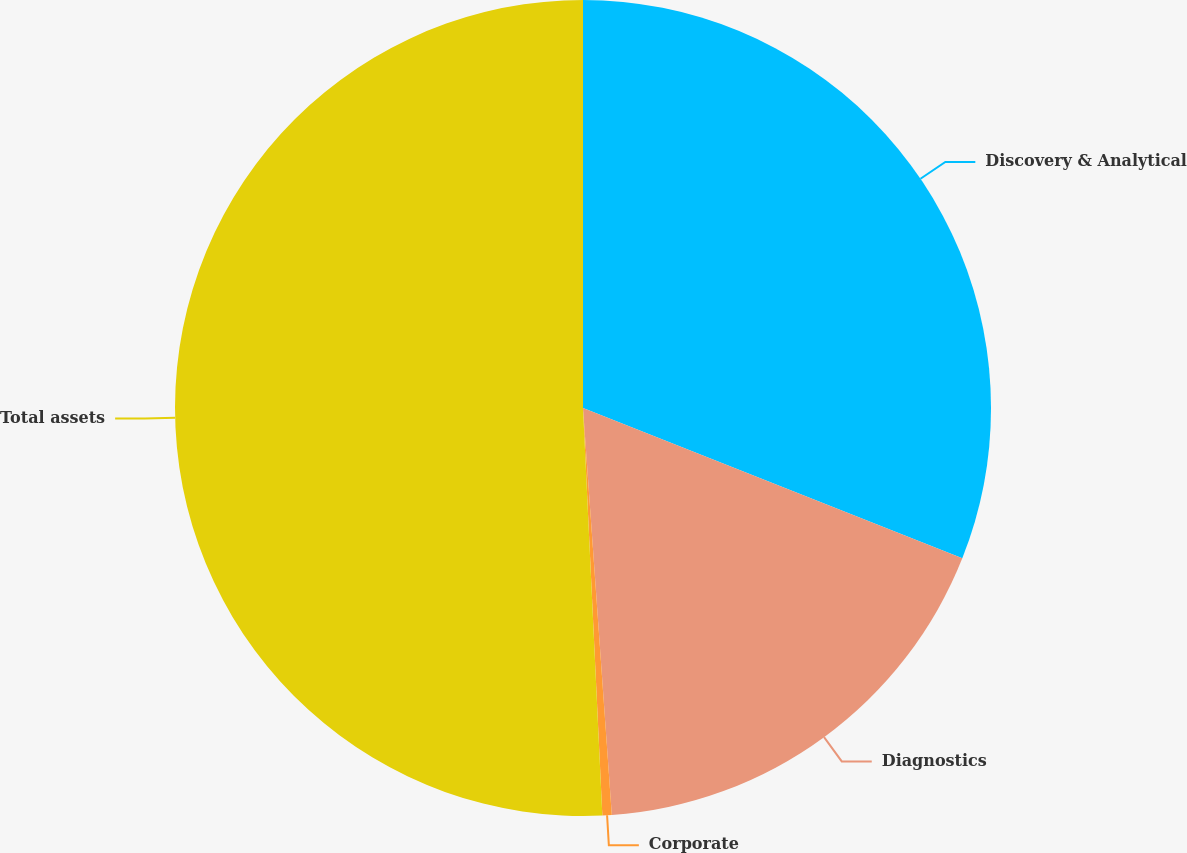Convert chart. <chart><loc_0><loc_0><loc_500><loc_500><pie_chart><fcel>Discovery & Analytical<fcel>Diagnostics<fcel>Corporate<fcel>Total assets<nl><fcel>31.01%<fcel>17.87%<fcel>0.37%<fcel>50.76%<nl></chart> 